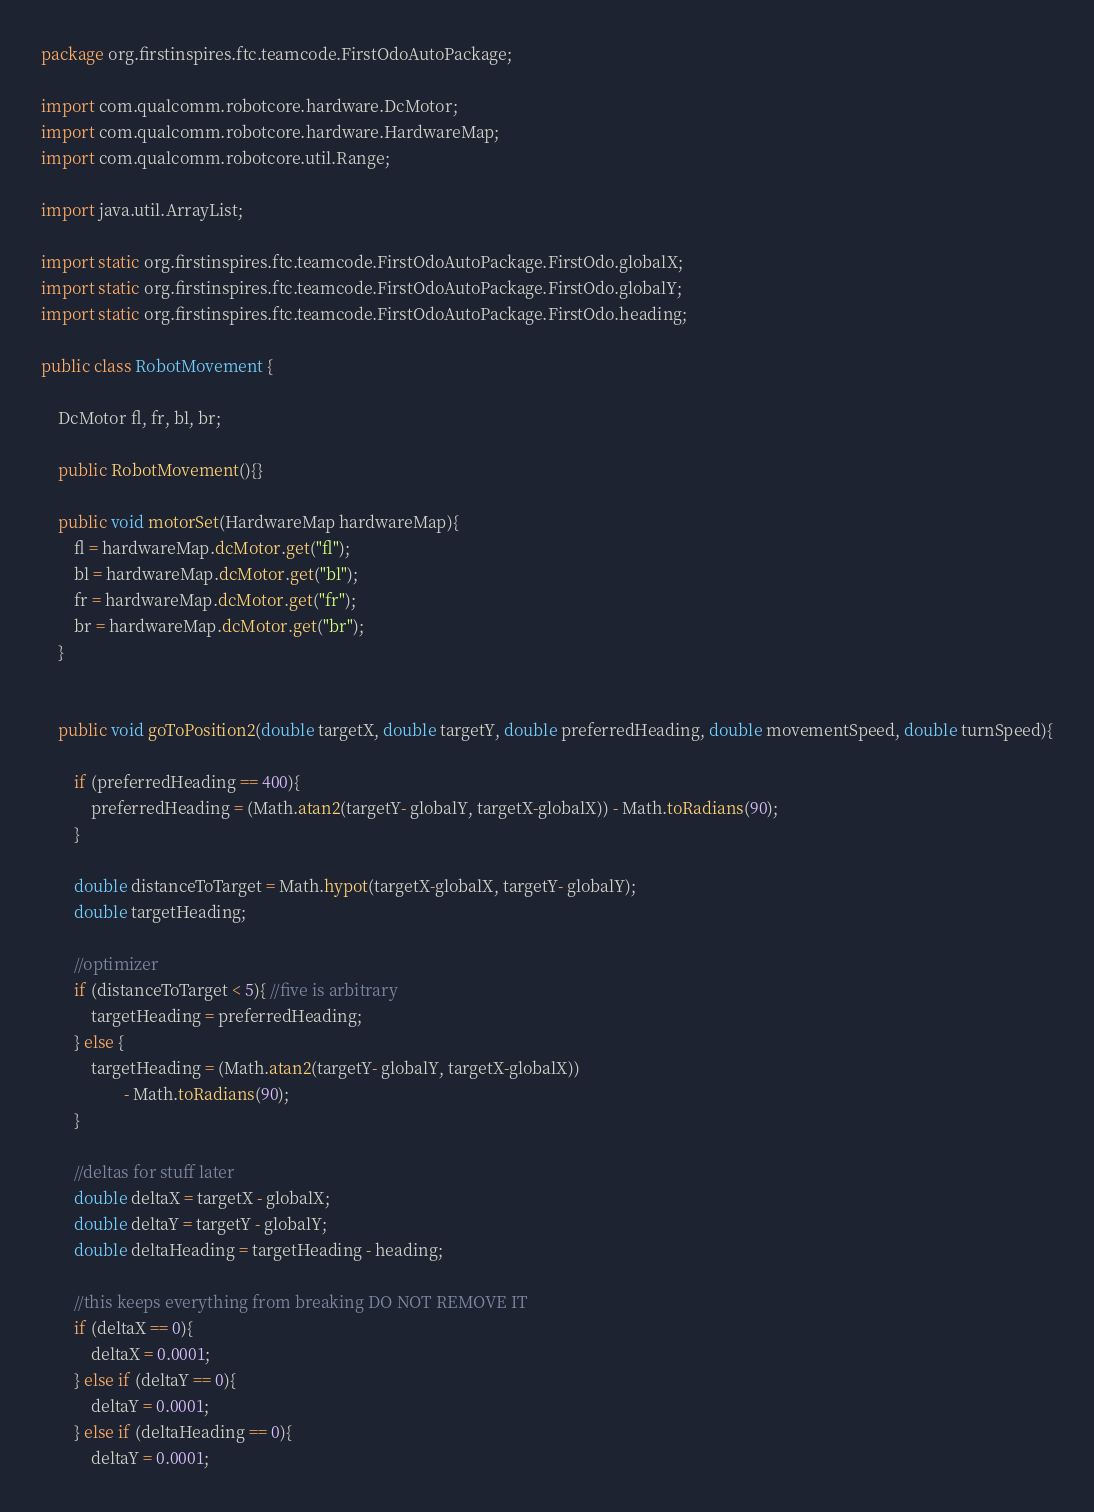Convert code to text. <code><loc_0><loc_0><loc_500><loc_500><_Java_>package org.firstinspires.ftc.teamcode.FirstOdoAutoPackage;

import com.qualcomm.robotcore.hardware.DcMotor;
import com.qualcomm.robotcore.hardware.HardwareMap;
import com.qualcomm.robotcore.util.Range;

import java.util.ArrayList;

import static org.firstinspires.ftc.teamcode.FirstOdoAutoPackage.FirstOdo.globalX;
import static org.firstinspires.ftc.teamcode.FirstOdoAutoPackage.FirstOdo.globalY;
import static org.firstinspires.ftc.teamcode.FirstOdoAutoPackage.FirstOdo.heading;

public class RobotMovement {

    DcMotor fl, fr, bl, br;

    public RobotMovement(){}

    public void motorSet(HardwareMap hardwareMap){
        fl = hardwareMap.dcMotor.get("fl");
        bl = hardwareMap.dcMotor.get("bl");
        fr = hardwareMap.dcMotor.get("fr");
        br = hardwareMap.dcMotor.get("br");
    }


    public void goToPosition2(double targetX, double targetY, double preferredHeading, double movementSpeed, double turnSpeed){

        if (preferredHeading == 400){
            preferredHeading = (Math.atan2(targetY- globalY, targetX-globalX)) - Math.toRadians(90);
        }

        double distanceToTarget = Math.hypot(targetX-globalX, targetY- globalY);
        double targetHeading;

        //optimizer
        if (distanceToTarget < 5){ //five is arbitrary
            targetHeading = preferredHeading;
        } else {
            targetHeading = (Math.atan2(targetY- globalY, targetX-globalX))
                    - Math.toRadians(90);
        }

        //deltas for stuff later
        double deltaX = targetX - globalX;
        double deltaY = targetY - globalY;
        double deltaHeading = targetHeading - heading;

        //this keeps everything from breaking DO NOT REMOVE IT
        if (deltaX == 0){
            deltaX = 0.0001;
        } else if (deltaY == 0){
            deltaY = 0.0001;
        } else if (deltaHeading == 0){
            deltaY = 0.0001;</code> 